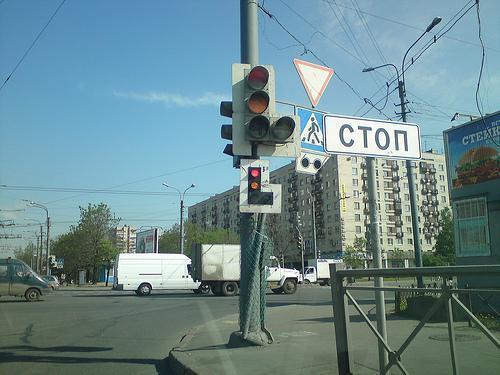How many signs are shaped like triangles?
Give a very brief answer. 2. 